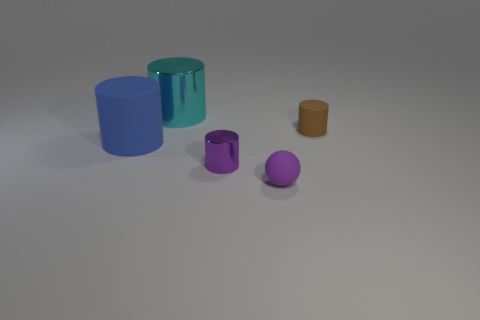Subtract all purple cylinders. Subtract all brown blocks. How many cylinders are left? 3 Add 5 blue cylinders. How many objects exist? 10 Subtract all cylinders. How many objects are left? 1 Add 2 small brown matte cylinders. How many small brown matte cylinders are left? 3 Add 4 cyan metallic cylinders. How many cyan metallic cylinders exist? 5 Subtract 0 blue cubes. How many objects are left? 5 Subtract all big matte cylinders. Subtract all large yellow matte spheres. How many objects are left? 4 